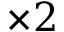<formula> <loc_0><loc_0><loc_500><loc_500>\times 2</formula> 